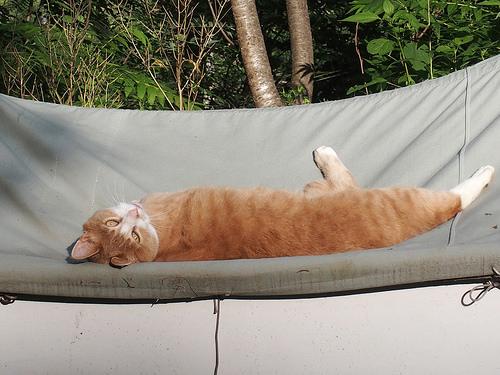<image>
Can you confirm if the cat is on the hammock? Yes. Looking at the image, I can see the cat is positioned on top of the hammock, with the hammock providing support. Where is the cat in relation to the tree? Is it on the tree? No. The cat is not positioned on the tree. They may be near each other, but the cat is not supported by or resting on top of the tree. Is the cat in front of the tree? Yes. The cat is positioned in front of the tree, appearing closer to the camera viewpoint. 